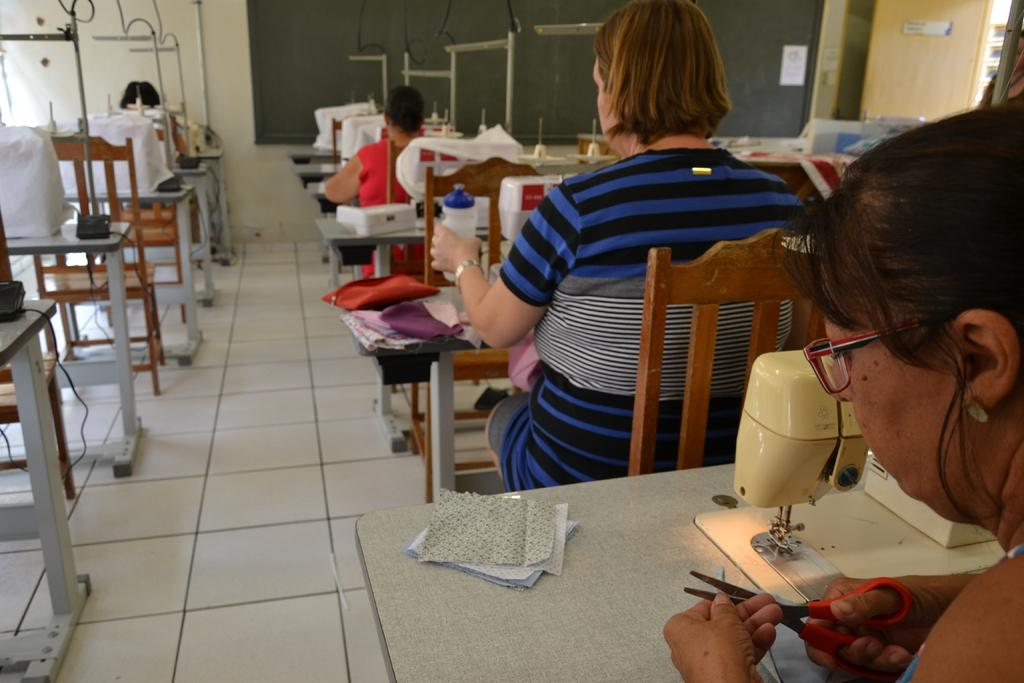What type of class is taking place in the image? It is a sewing class. What equipment is being used in the class? There are sewing machines on the tables. What are the people in the image doing? People are working with the sewing machines. What is at the front of the room? There is a blackboard in the front of the room. What color is the wall beside the blackboard? There is a cream-colored wall beside the blackboard. Can you see your dad playing soccer in the field in the image? There is no soccer field or dad present in the image; it is a sewing class with sewing machines and people working on them. 